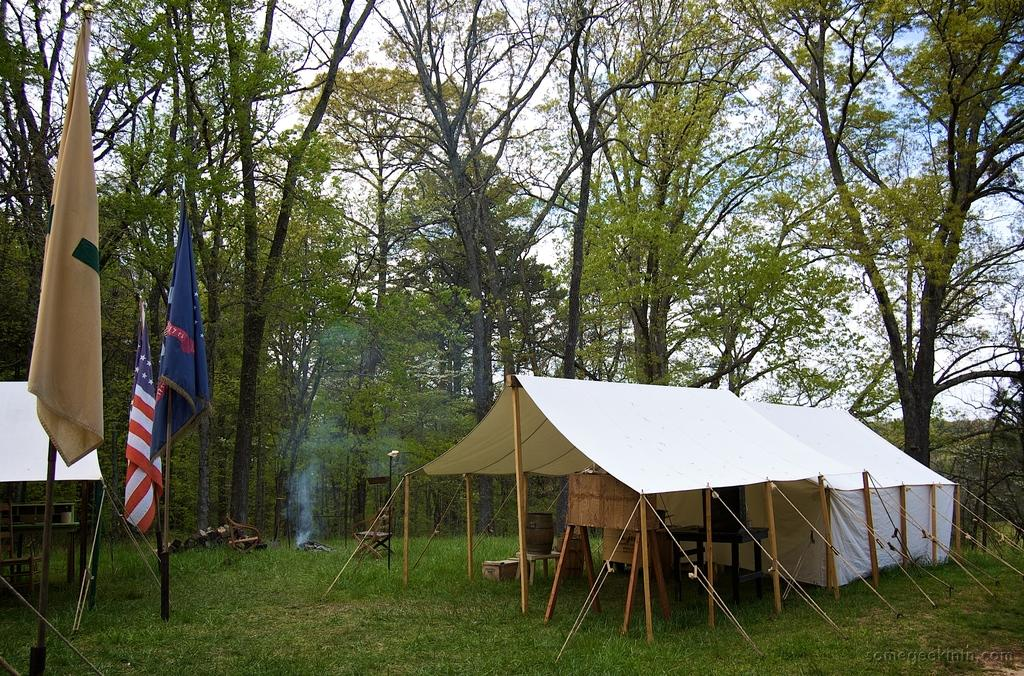What type of temporary shelters can be seen in the image? There are tents in the image. What items can be found inside the tents? Wooden sticks, a table, a speaker, chairs, and flags are present inside the tents. What structure is visible in the tents? There is a stand in the tents. What type of natural environment is visible in the image? Trees, grass, and the sky are visible in the image. Can you see the father wearing a crown in the image? There is no father or crown present in the image. What type of bubble can be seen in the image? There is no bubble present in the image. 